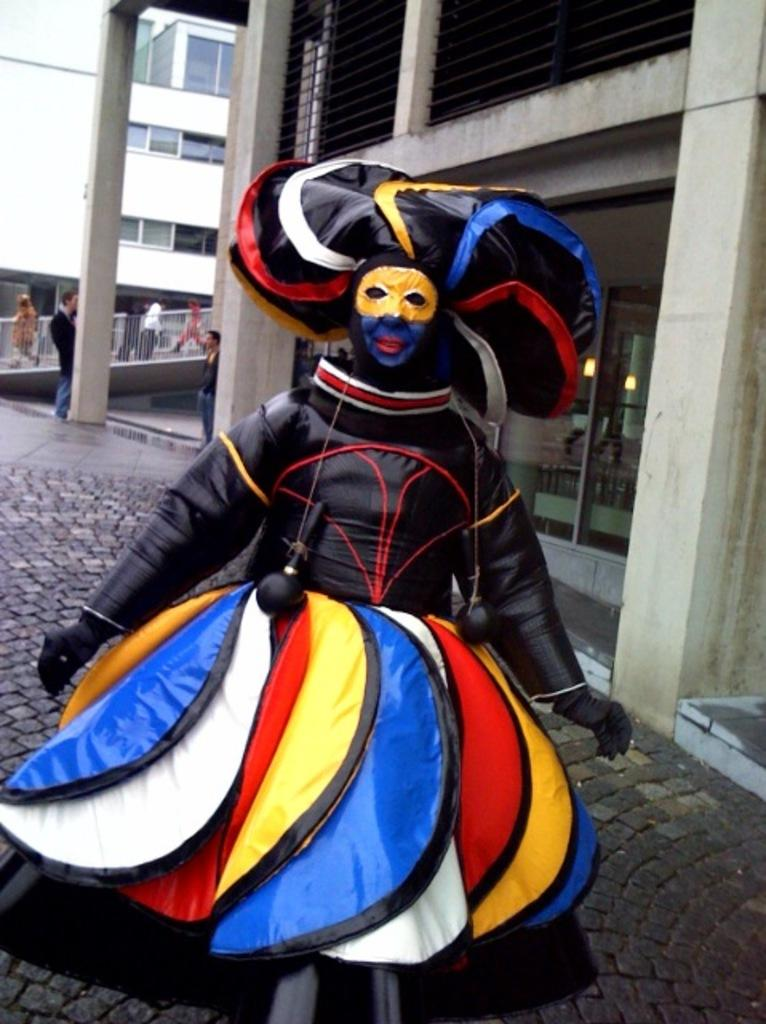What is the main subject in the front of the image? There is a person standing in the front of the image. Can you describe the person's attire? The person is wearing a black and colorful costume. What can be seen in the background of the image? There is a building behind the person. What is happening on the left side of the image? There are people walking on the left side of the image. What type of thought is the person having while holding an umbrella in the image? There is no umbrella present in the image, and therefore no thought related to an umbrella can be inferred. 